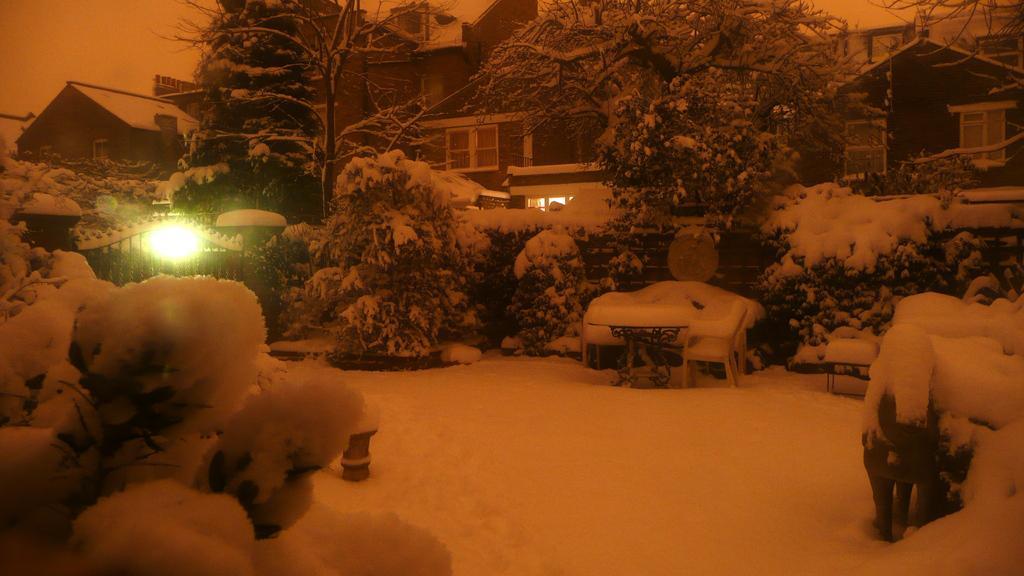In one or two sentences, can you explain what this image depicts? In the foreground of the image we can see snow and trees on which snow is there. In the middle of the image we can see a table and bench on which snow is there. We can see a gate, light and some trees. On the top of the image we can see houses and trees. 